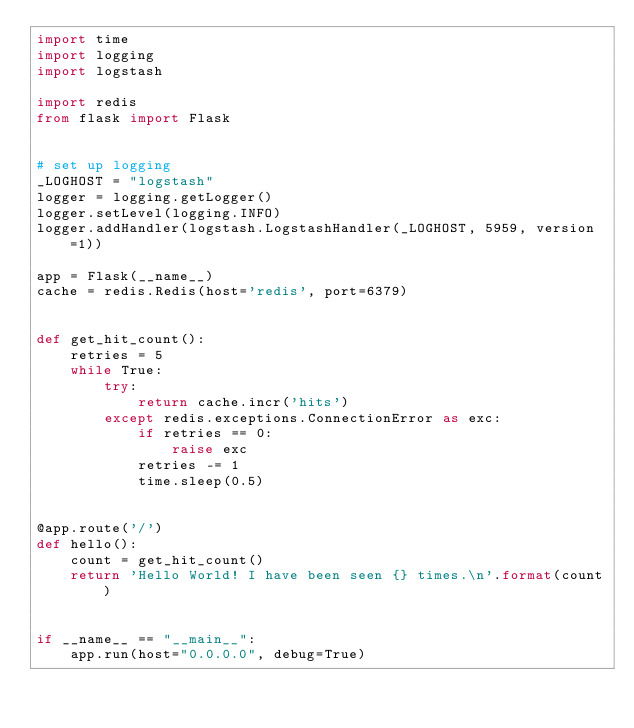<code> <loc_0><loc_0><loc_500><loc_500><_Python_>import time
import logging
import logstash

import redis
from flask import Flask


# set up logging
_LOGHOST = "logstash"
logger = logging.getLogger()
logger.setLevel(logging.INFO)
logger.addHandler(logstash.LogstashHandler(_LOGHOST, 5959, version=1))

app = Flask(__name__)
cache = redis.Redis(host='redis', port=6379)


def get_hit_count():
    retries = 5
    while True:
        try:
            return cache.incr('hits')
        except redis.exceptions.ConnectionError as exc:
            if retries == 0:
                raise exc
            retries -= 1
            time.sleep(0.5)


@app.route('/')
def hello():
    count = get_hit_count()
    return 'Hello World! I have been seen {} times.\n'.format(count)


if __name__ == "__main__":
    app.run(host="0.0.0.0", debug=True)
</code> 